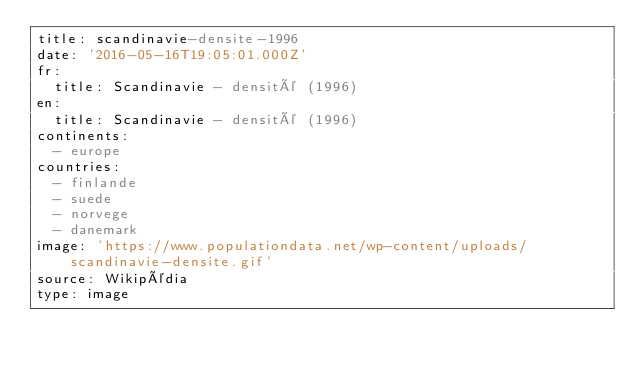<code> <loc_0><loc_0><loc_500><loc_500><_YAML_>title: scandinavie-densite-1996
date: '2016-05-16T19:05:01.000Z'
fr:
  title: Scandinavie - densité (1996)
en:
  title: Scandinavie - densité (1996)
continents:
  - europe
countries:
  - finlande
  - suede
  - norvege
  - danemark
image: 'https://www.populationdata.net/wp-content/uploads/scandinavie-densite.gif'
source: Wikipédia
type: image
</code> 